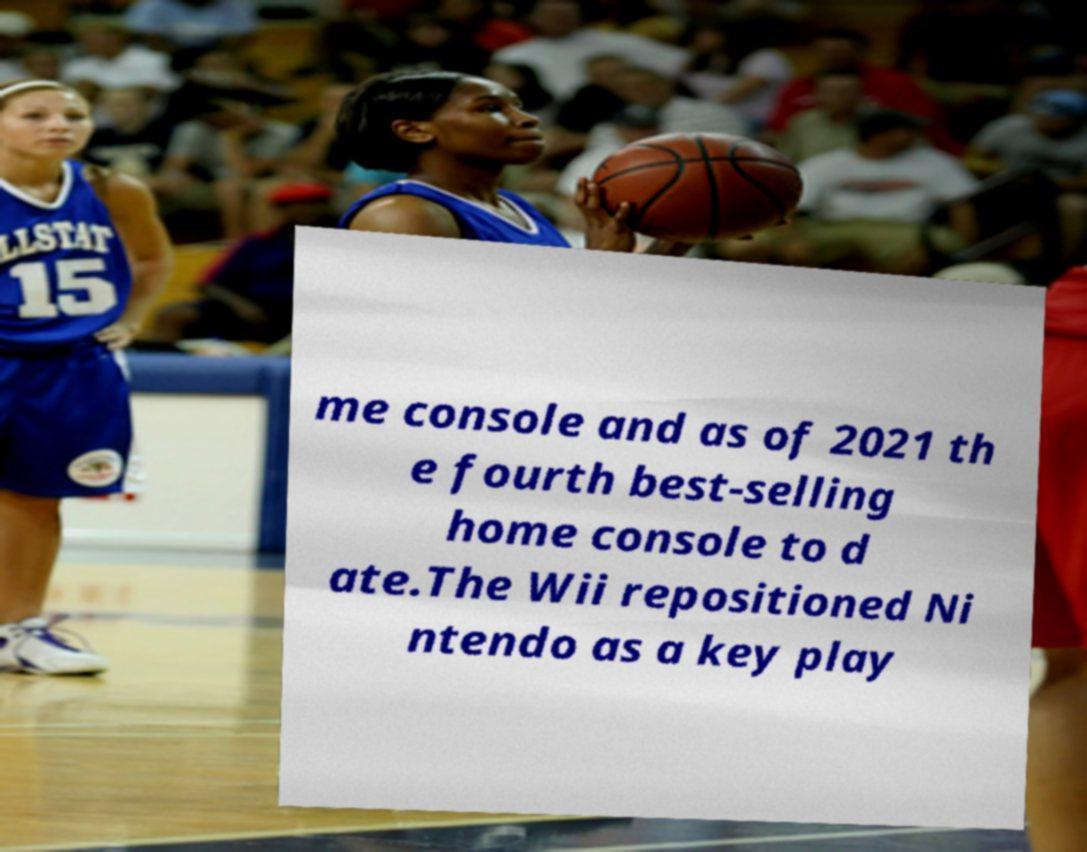I need the written content from this picture converted into text. Can you do that? me console and as of 2021 th e fourth best-selling home console to d ate.The Wii repositioned Ni ntendo as a key play 